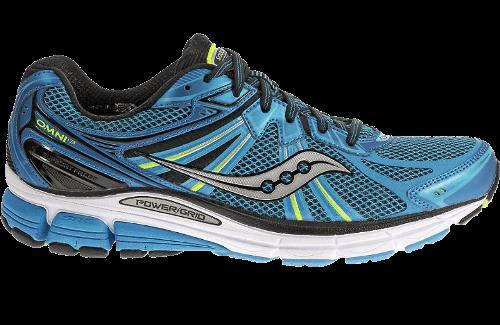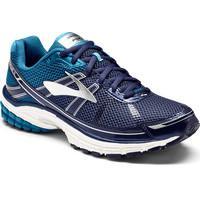The first image is the image on the left, the second image is the image on the right. Examine the images to the left and right. Is the description "There is at least one sneaker that is mainly gray and has blue laces." accurate? Answer yes or no. No. 